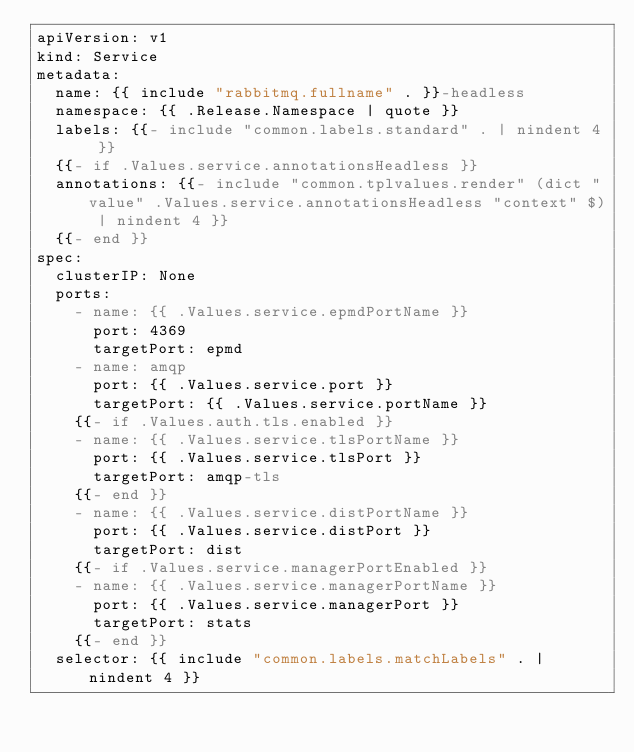<code> <loc_0><loc_0><loc_500><loc_500><_YAML_>apiVersion: v1
kind: Service
metadata:
  name: {{ include "rabbitmq.fullname" . }}-headless
  namespace: {{ .Release.Namespace | quote }}
  labels: {{- include "common.labels.standard" . | nindent 4 }}
  {{- if .Values.service.annotationsHeadless }}
  annotations: {{- include "common.tplvalues.render" (dict "value" .Values.service.annotationsHeadless "context" $) | nindent 4 }}
  {{- end }}
spec:
  clusterIP: None
  ports:
    - name: {{ .Values.service.epmdPortName }}
      port: 4369
      targetPort: epmd
    - name: amqp
      port: {{ .Values.service.port }}
      targetPort: {{ .Values.service.portName }}
    {{- if .Values.auth.tls.enabled }}
    - name: {{ .Values.service.tlsPortName }}
      port: {{ .Values.service.tlsPort }}
      targetPort: amqp-tls
    {{- end }}
    - name: {{ .Values.service.distPortName }}
      port: {{ .Values.service.distPort }}
      targetPort: dist
    {{- if .Values.service.managerPortEnabled }}
    - name: {{ .Values.service.managerPortName }}
      port: {{ .Values.service.managerPort }}
      targetPort: stats
    {{- end }}
  selector: {{ include "common.labels.matchLabels" . | nindent 4 }}
</code> 